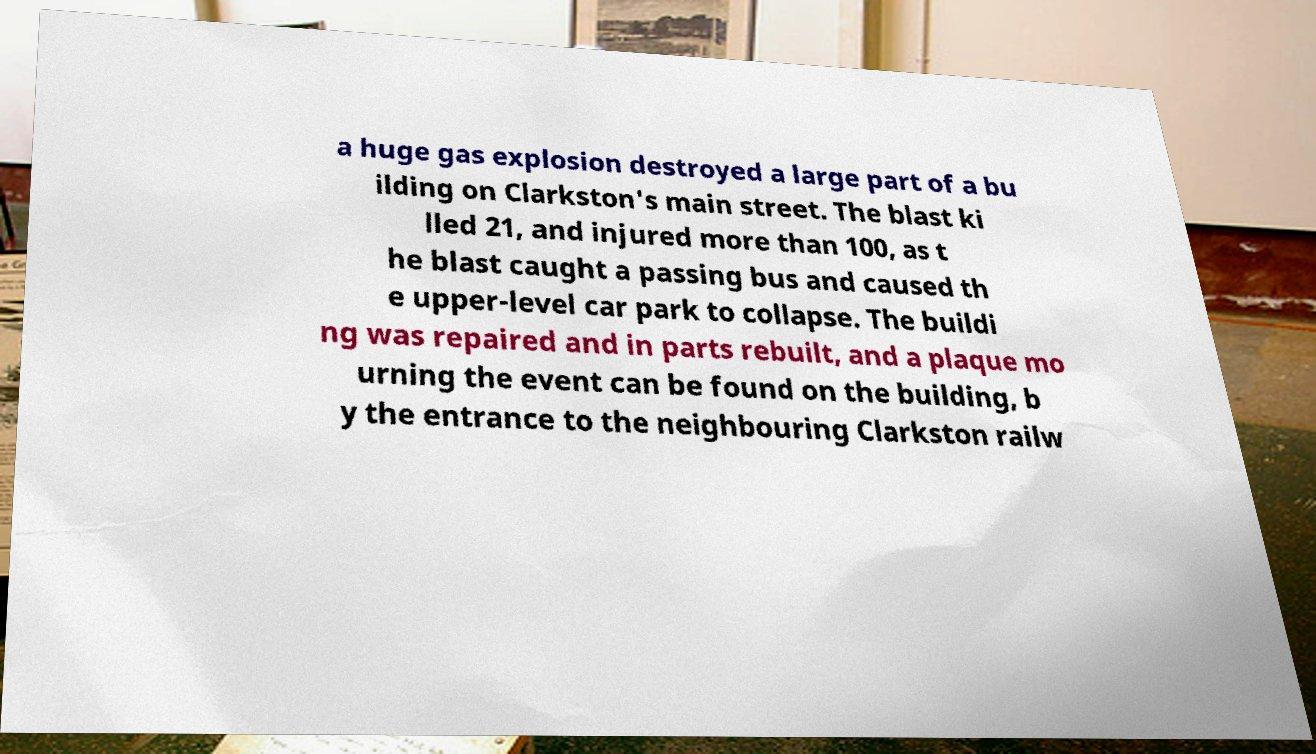Could you extract and type out the text from this image? a huge gas explosion destroyed a large part of a bu ilding on Clarkston's main street. The blast ki lled 21, and injured more than 100, as t he blast caught a passing bus and caused th e upper-level car park to collapse. The buildi ng was repaired and in parts rebuilt, and a plaque mo urning the event can be found on the building, b y the entrance to the neighbouring Clarkston railw 